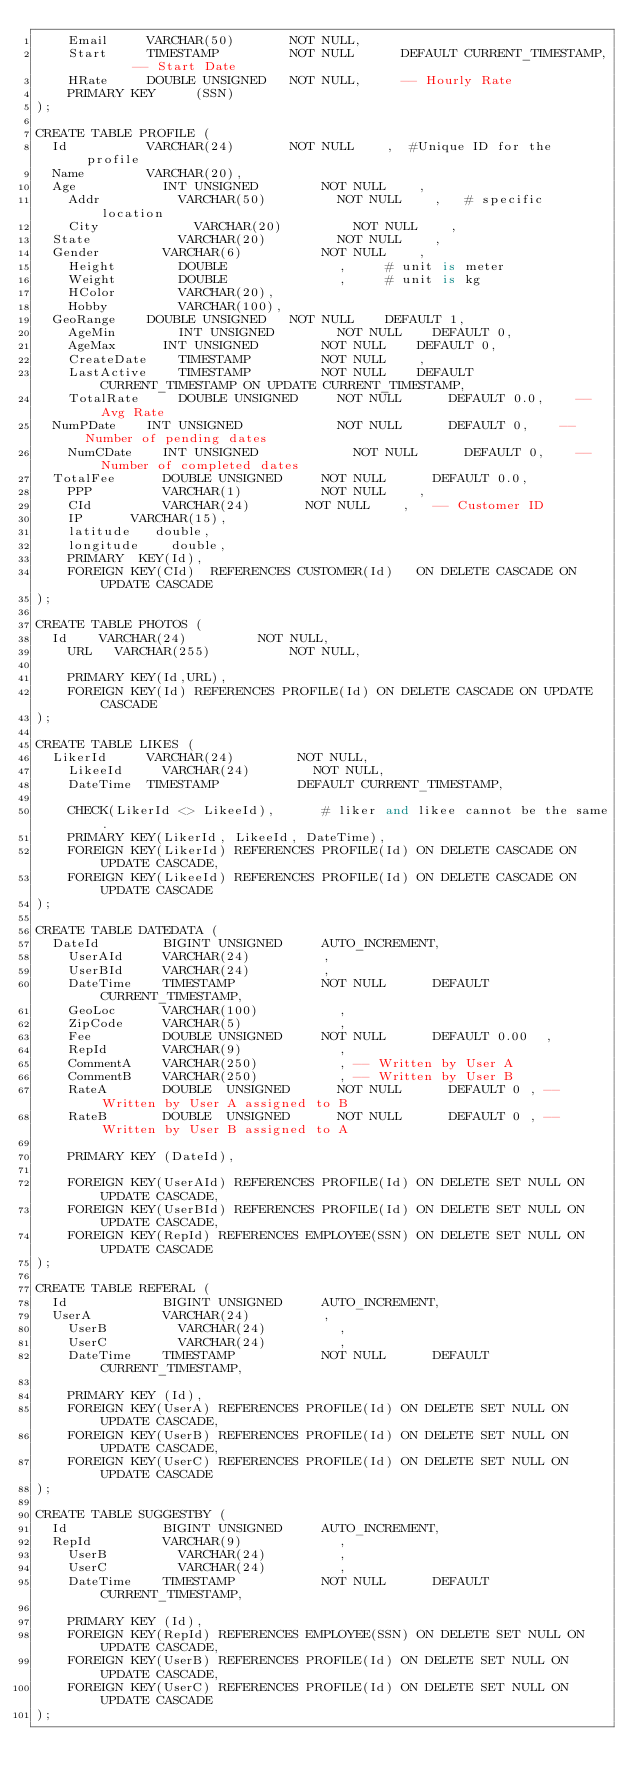Convert code to text. <code><loc_0><loc_0><loc_500><loc_500><_SQL_>    Email			VARCHAR(50)				NOT NULL,
    Start			TIMESTAMP					NOT NULL			DEFAULT CURRENT_TIMESTAMP,		-- Start Date
    HRate			DOUBLE UNSIGNED		NOT NULL,			-- Hourly Rate
    PRIMARY KEY     (SSN)
);

CREATE TABLE PROFILE (
	Id 		 			VARCHAR(24)		 		NOT NULL   	,  #Unique ID for the profile 
	Name 	 			VARCHAR(20), 
	Age   	 			INT UNSIGNED		 		NOT NULL 		,
    Addr     			VARCHAR(50) 				NOT NULL 		,   # specific location
    City     				VARCHAR(20) 				NOT NULL   	, 
	State   				VARCHAR(20) 				NOT NULL		,
	Gender   			VARCHAR(6)  				NOT NULL 		,
    Height   			DOUBLE							,     # unit is meter
    Weight   			DOUBLE							,     # unit is kg
    HColor   			VARCHAR(20),
    Hobby    			VARCHAR(100),
	GeoRange 		DOUBLE UNSIGNED 	NOT NULL 		DEFAULT 1,
    AgeMin   			INT UNSIGNED 		 		NOT NULL		DEFAULT 0,
    AgeMax   		INT UNSIGNED 				NOT NULL		DEFAULT 0,
    CreateDate		TIMESTAMP					NOT NULL		,
    LastActive		TIMESTAMP					NOT NULL		DEFAULT CURRENT_TIMESTAMP ON UPDATE CURRENT_TIMESTAMP,
    TotalRate			DOUBLE UNSIGNED     NOT NULL    	DEFAULT 0.0,		-- Avg Rate
	NumPDate		INT UNSIGNED        		NOT NULL    	DEFAULT 0,		-- Number of pending dates
    NumCDate		INT UNSIGNED        		NOT NULL    	DEFAULT 0,		-- Number of completed dates
	TotalFee			DOUBLE UNSIGNED     NOT NULL    	DEFAULT 0.0,
    PPP					VARCHAR(1)					NOT NULL 		,
    CId					VARCHAR(24)				NOT NULL		,		-- Customer ID
    IP  		VARCHAR(15),   
    latitude 	 double,
    longitude    double,
    PRIMARY  KEY(Id),
    FOREIGN KEY(CId) 	REFERENCES CUSTOMER(Id) 	ON DELETE CASCADE ON UPDATE CASCADE
);

CREATE TABLE PHOTOS (
	Id 		VARCHAR(24)		 			NOT NULL,
    URL		VARCHAR(255) 			 		NOT NULL,
    
    PRIMARY KEY(Id,URL),
    FOREIGN KEY(Id) REFERENCES PROFILE(Id) ON DELETE CASCADE ON UPDATE CASCADE
);    

CREATE TABLE LIKES (
	LikerId 		VARCHAR(24)		 		 NOT NULL,
    LikeeId 		VARCHAR(24)		 		 NOT NULL,
    DateTime 	TIMESTAMP			 		 DEFAULT CURRENT_TIMESTAMP,
    
    CHECK(LikerId <> LikeeId),      # liker and likee cannot be the same.
    PRIMARY KEY(LikerId, LikeeId, DateTime),
    FOREIGN KEY(LikerId) REFERENCES PROFILE(Id) ON DELETE CASCADE ON UPDATE CASCADE,
    FOREIGN KEY(LikeeId) REFERENCES PROFILE(Id) ON DELETE CASCADE ON UPDATE CASCADE
);

CREATE TABLE DATEDATA (
	DateId				BIGINT UNSIGNED			AUTO_INCREMENT,
    UserAId			VARCHAR(24)					,
    UserBId			VARCHAR(24)					,
    DateTime		TIMESTAMP						NOT NULL			DEFAULT CURRENT_TIMESTAMP,
    GeoLoc			VARCHAR(100)					,
    ZipCode			VARCHAR(5)						,
    Fee					DOUBLE UNSIGNED			NOT NULL			DEFAULT 0.00	,
    RepId				VARCHAR(9)						,
    CommentA		VARCHAR(250)					,	-- Written by User A
    CommentB		VARCHAR(250)					,	-- Written by User B
    RateA				DOUBLE	UNSIGNED			NOT NULL			DEFAULT 0	,	-- Written by User A assigned to B
    RateB				DOUBLE	UNSIGNED			NOT NULL			DEFAULT 0	,	-- Written by User B assigned to A
    
    PRIMARY KEY (DateId), 
    
    FOREIGN KEY(UserAId) REFERENCES PROFILE(Id) ON DELETE SET NULL ON UPDATE CASCADE,
    FOREIGN KEY(UserBId) REFERENCES PROFILE(Id) ON DELETE SET NULL ON UPDATE CASCADE,
    FOREIGN KEY(RepId) REFERENCES EMPLOYEE(SSN) ON DELETE SET NULL ON UPDATE CASCADE
);

CREATE TABLE REFERAL (
	Id						BIGINT UNSIGNED			AUTO_INCREMENT,
	UserA 				VARCHAR(24)					,
    UserB 				VARCHAR(24)					,
    UserC 				VARCHAR(24)					,
    DateTime		TIMESTAMP						NOT NULL			DEFAULT CURRENT_TIMESTAMP,
    
    PRIMARY KEY (Id),
    FOREIGN KEY(UserA) REFERENCES PROFILE(Id) ON DELETE SET NULL ON UPDATE CASCADE,
    FOREIGN KEY(UserB) REFERENCES PROFILE(Id) ON DELETE SET NULL ON UPDATE CASCADE,
    FOREIGN KEY(UserC) REFERENCES PROFILE(Id) ON DELETE SET NULL ON UPDATE CASCADE
);

CREATE TABLE SUGGESTBY (
	Id						BIGINT UNSIGNED			AUTO_INCREMENT,
	RepId 				VARCHAR(9)						,
    UserB 				VARCHAR(24)					,
    UserC 				VARCHAR(24)					,
    DateTime		TIMESTAMP						NOT NULL			DEFAULT CURRENT_TIMESTAMP,
    
    PRIMARY KEY (Id),
    FOREIGN KEY(RepId) REFERENCES EMPLOYEE(SSN) ON DELETE SET NULL ON UPDATE CASCADE,
    FOREIGN KEY(UserB) REFERENCES PROFILE(Id) ON DELETE SET NULL ON UPDATE CASCADE,
    FOREIGN KEY(UserC) REFERENCES PROFILE(Id) ON DELETE SET NULL ON UPDATE CASCADE
);



</code> 